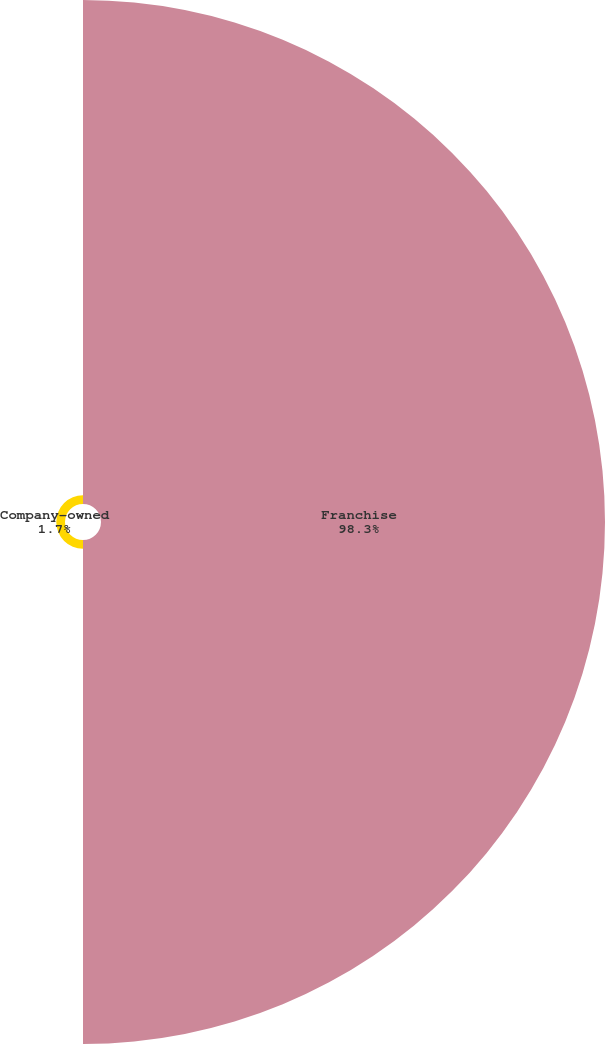Convert chart. <chart><loc_0><loc_0><loc_500><loc_500><pie_chart><fcel>Franchise<fcel>Company-owned<nl><fcel>98.3%<fcel>1.7%<nl></chart> 